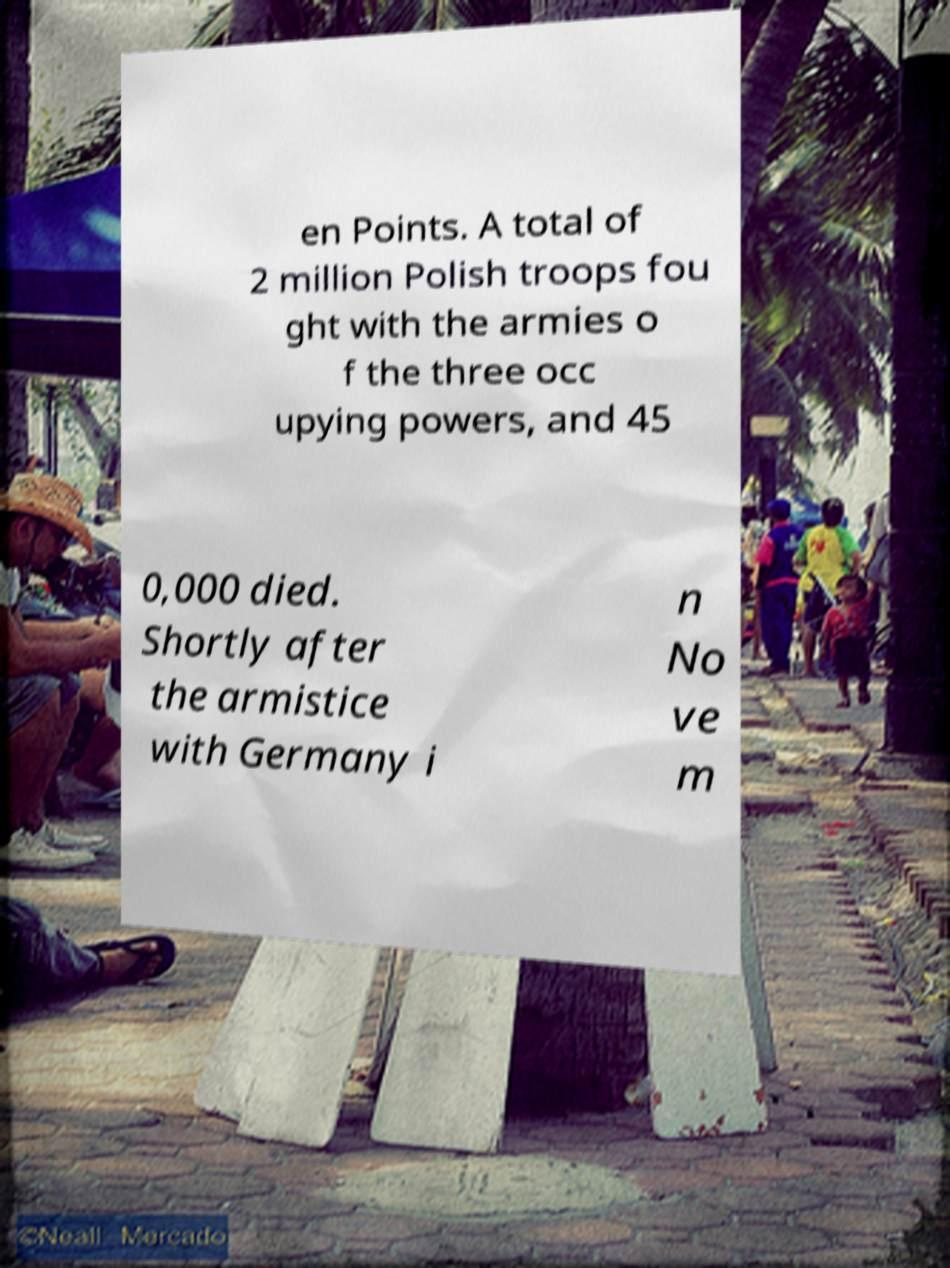Can you accurately transcribe the text from the provided image for me? en Points. A total of 2 million Polish troops fou ght with the armies o f the three occ upying powers, and 45 0,000 died. Shortly after the armistice with Germany i n No ve m 